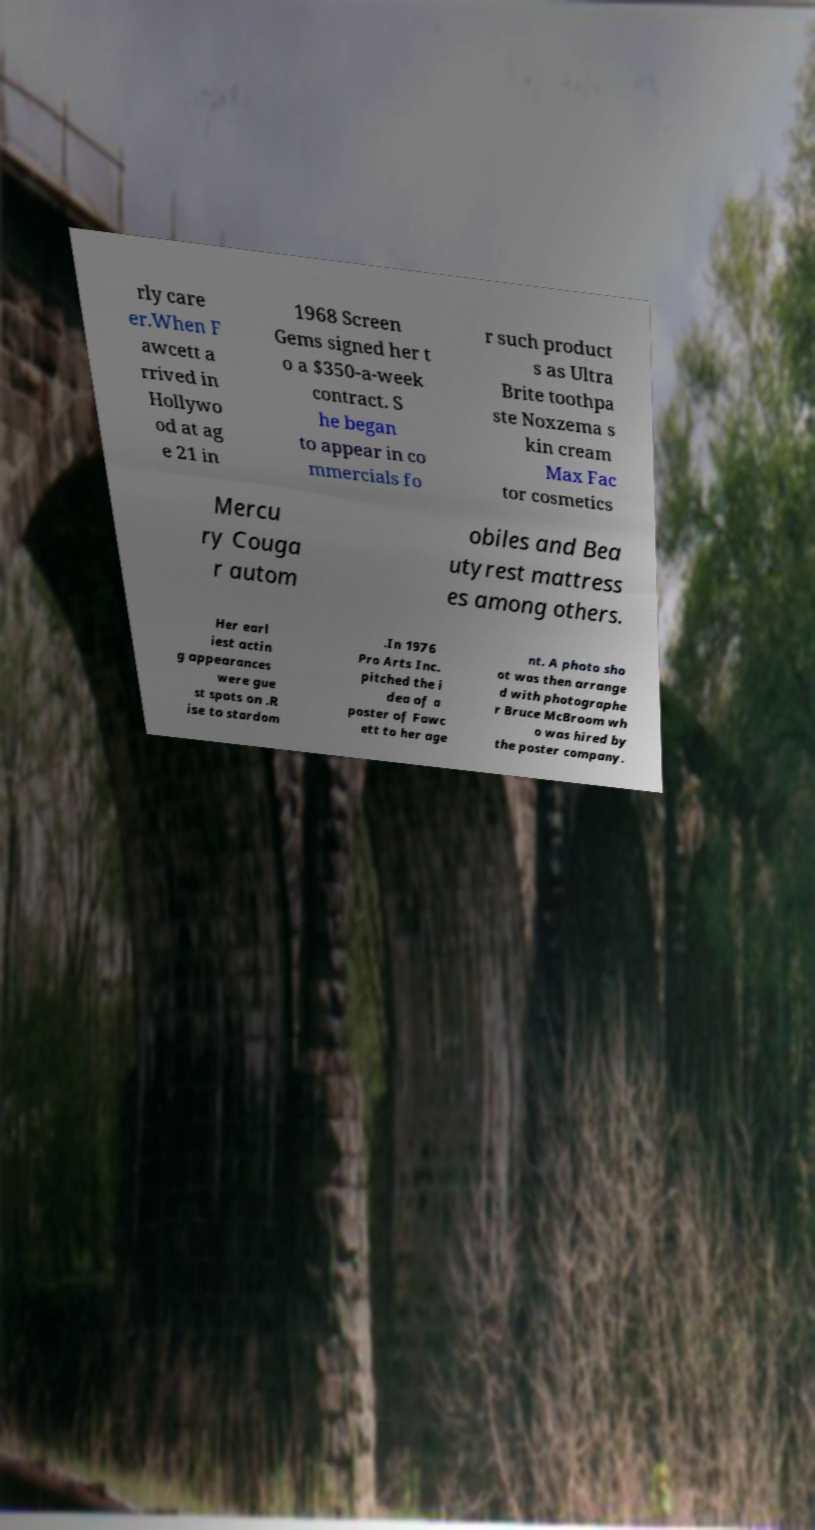Can you accurately transcribe the text from the provided image for me? rly care er.When F awcett a rrived in Hollywo od at ag e 21 in 1968 Screen Gems signed her t o a $350-a-week contract. S he began to appear in co mmercials fo r such product s as Ultra Brite toothpa ste Noxzema s kin cream Max Fac tor cosmetics Mercu ry Couga r autom obiles and Bea utyrest mattress es among others. Her earl iest actin g appearances were gue st spots on .R ise to stardom .In 1976 Pro Arts Inc. pitched the i dea of a poster of Fawc ett to her age nt. A photo sho ot was then arrange d with photographe r Bruce McBroom wh o was hired by the poster company. 